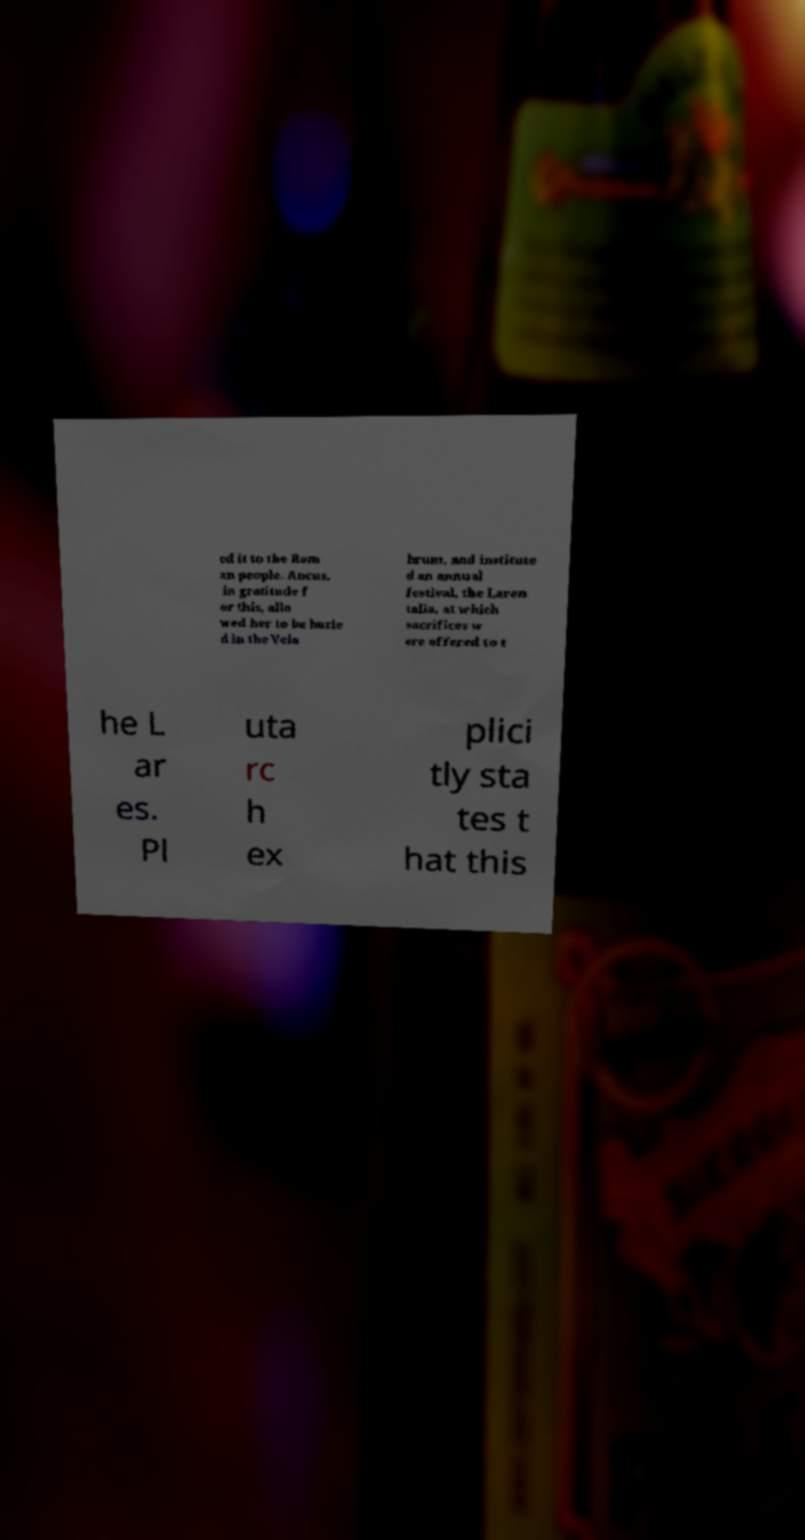There's text embedded in this image that I need extracted. Can you transcribe it verbatim? ed it to the Rom an people. Ancus, in gratitude f or this, allo wed her to be burie d in the Vela brum, and institute d an annual festival, the Laren talia, at which sacrifices w ere offered to t he L ar es. Pl uta rc h ex plici tly sta tes t hat this 